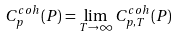Convert formula to latex. <formula><loc_0><loc_0><loc_500><loc_500>C _ { p } ^ { c o h } ( P ) = \lim _ { T \rightarrow \infty } C _ { p , T } ^ { c o h } ( P )</formula> 